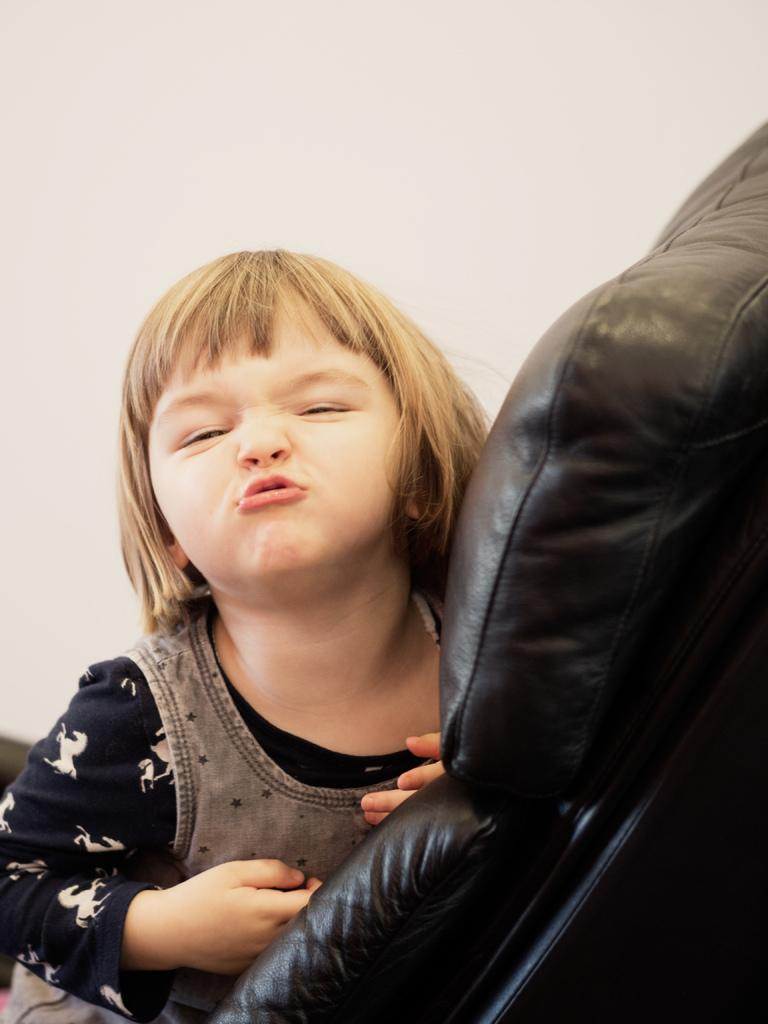Who is present in the image? There is a girl in the image. How is the girl's facial expression? The girl has a funky expression on her face. What is the girl sitting on? The girl is sitting on a black chair. What can be seen in the background of the image? There is a wall in the background of the image. What is the condition of the air in the image? There is no information about the air quality or condition in the image. How many pins are visible on the girl's clothing in the image? There are no pins visible on the girl's clothing in the image. 